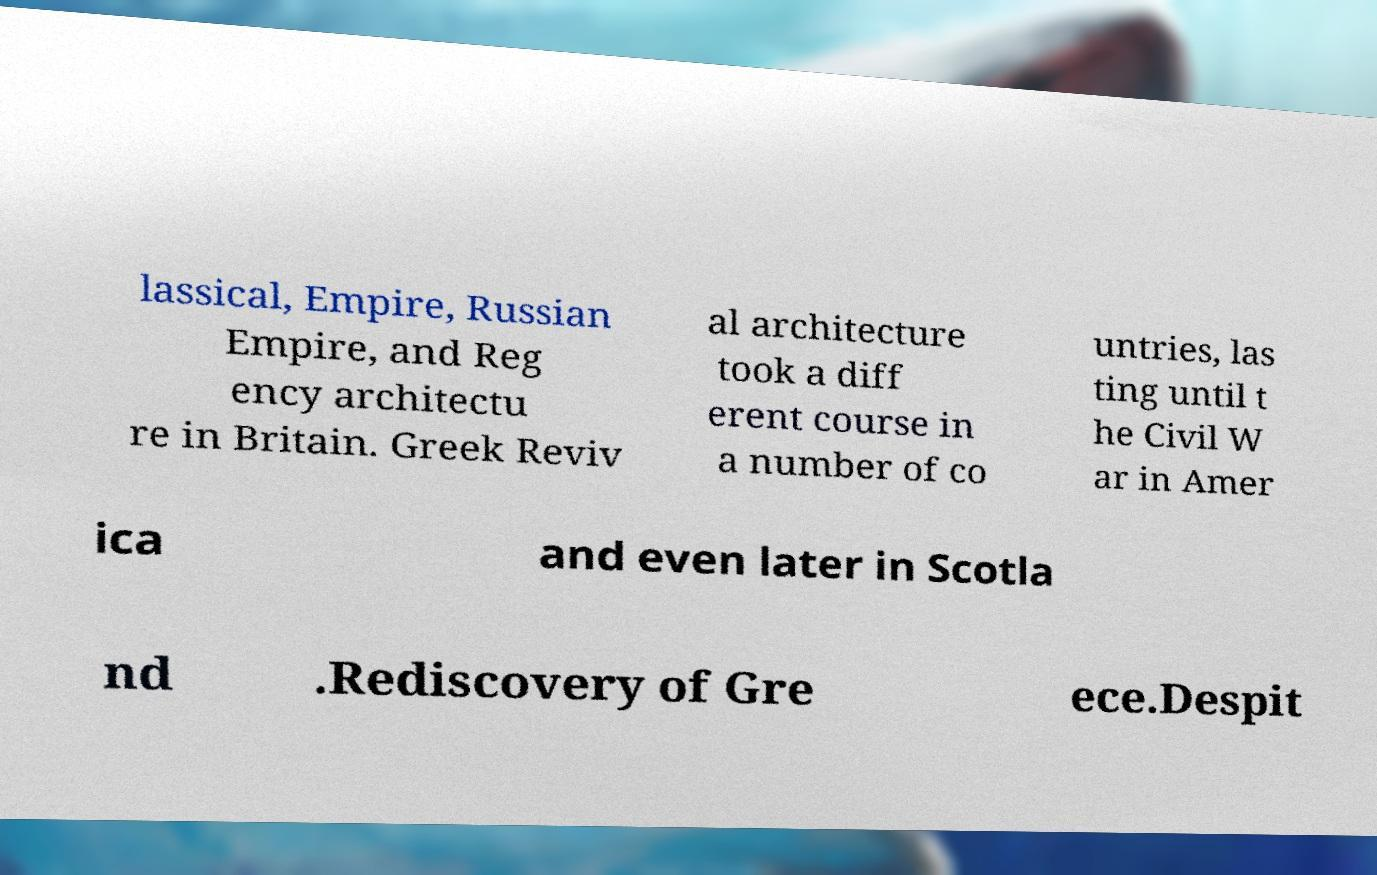Please read and relay the text visible in this image. What does it say? lassical, Empire, Russian Empire, and Reg ency architectu re in Britain. Greek Reviv al architecture took a diff erent course in a number of co untries, las ting until t he Civil W ar in Amer ica and even later in Scotla nd .Rediscovery of Gre ece.Despit 